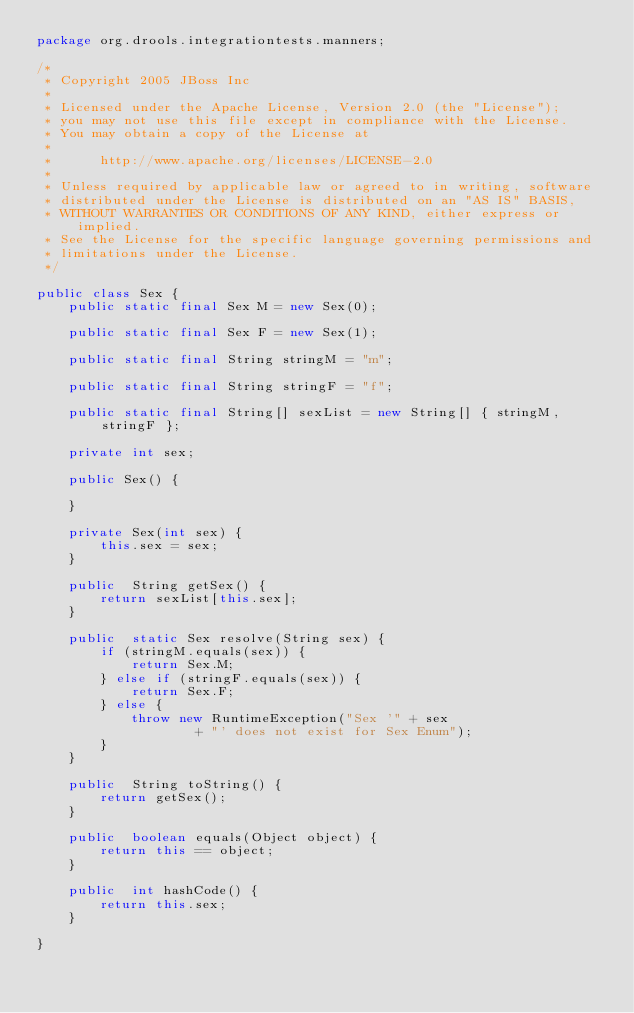Convert code to text. <code><loc_0><loc_0><loc_500><loc_500><_Java_>package org.drools.integrationtests.manners;

/*
 * Copyright 2005 JBoss Inc
 * 
 * Licensed under the Apache License, Version 2.0 (the "License");
 * you may not use this file except in compliance with the License.
 * You may obtain a copy of the License at
 * 
 *      http://www.apache.org/licenses/LICENSE-2.0
 * 
 * Unless required by applicable law or agreed to in writing, software
 * distributed under the License is distributed on an "AS IS" BASIS,
 * WITHOUT WARRANTIES OR CONDITIONS OF ANY KIND, either express or implied.
 * See the License for the specific language governing permissions and
 * limitations under the License.
 */

public class Sex {
	public static final Sex M = new Sex(0);

	public static final Sex F = new Sex(1);

	public static final String stringM = "m";

	public static final String stringF = "f";

	public static final String[] sexList = new String[] { stringM, stringF };

	private int sex;

	public Sex() {
		
	}
	
	private Sex(int sex) {
		this.sex = sex;
	}

	public  String getSex() {
		return sexList[this.sex];
	}

	public  static Sex resolve(String sex) {
		if (stringM.equals(sex)) {
			return Sex.M;
		} else if (stringF.equals(sex)) {
			return Sex.F;
		} else {
			throw new RuntimeException("Sex '" + sex
					+ "' does not exist for Sex Enum");
		}
	}

	public  String toString() {
		return getSex();
	}

	public  boolean equals(Object object) {
		return this == object;
	}

	public  int hashCode() {
		return this.sex;
	}

}</code> 